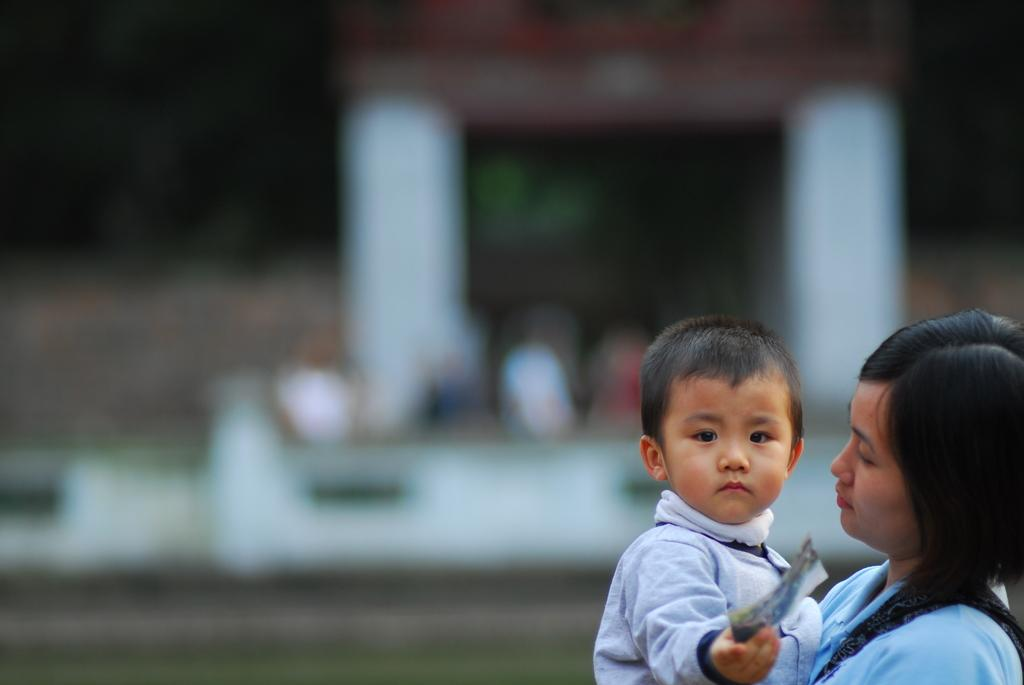Who is the main subject in the image? There is a boy in the image. What is the boy holding in his hand? The boy is holding an object in his hand. Are there any other people in the image? Yes, there is a woman in the image. How would you describe the background of the image? The background of the image is blurred. What is the value of the paste used by the group in the image? There is no group or paste present in the image; it features a boy and a woman. 